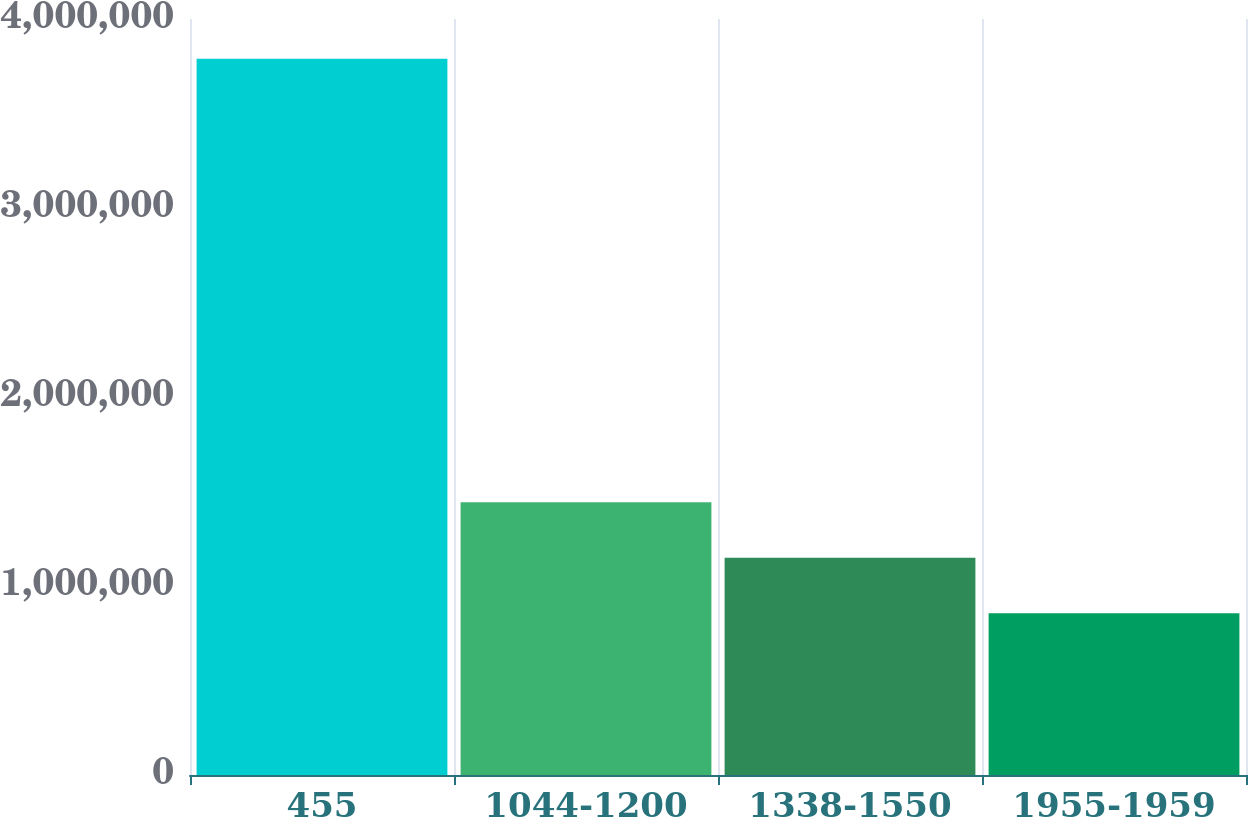<chart> <loc_0><loc_0><loc_500><loc_500><bar_chart><fcel>455<fcel>1044-1200<fcel>1338-1550<fcel>1955-1959<nl><fcel>3.79002e+06<fcel>1.44272e+06<fcel>1.14931e+06<fcel>855900<nl></chart> 